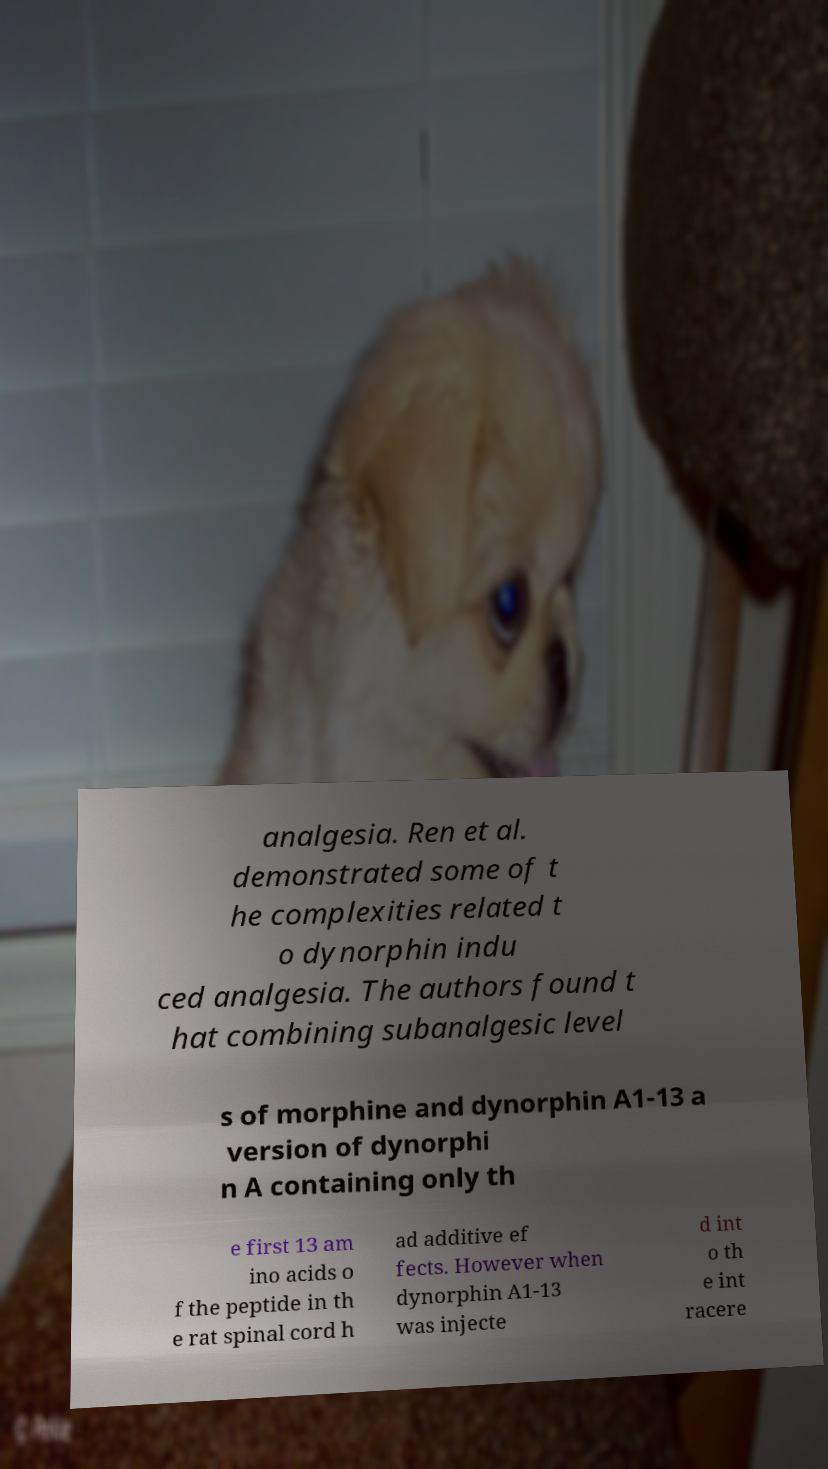I need the written content from this picture converted into text. Can you do that? analgesia. Ren et al. demonstrated some of t he complexities related t o dynorphin indu ced analgesia. The authors found t hat combining subanalgesic level s of morphine and dynorphin A1-13 a version of dynorphi n A containing only th e first 13 am ino acids o f the peptide in th e rat spinal cord h ad additive ef fects. However when dynorphin A1-13 was injecte d int o th e int racere 